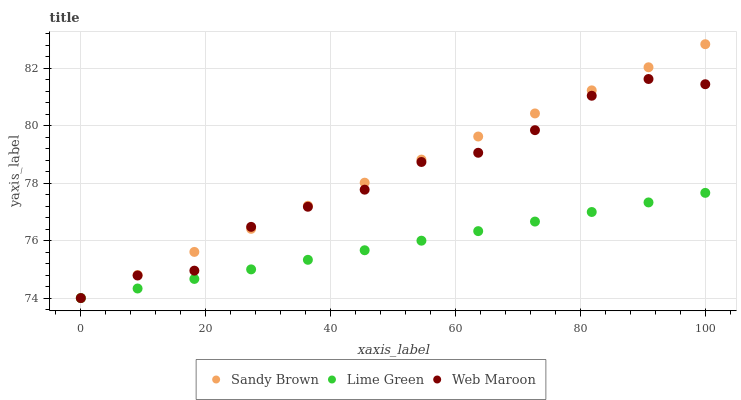Does Lime Green have the minimum area under the curve?
Answer yes or no. Yes. Does Sandy Brown have the maximum area under the curve?
Answer yes or no. Yes. Does Web Maroon have the minimum area under the curve?
Answer yes or no. No. Does Web Maroon have the maximum area under the curve?
Answer yes or no. No. Is Lime Green the smoothest?
Answer yes or no. Yes. Is Web Maroon the roughest?
Answer yes or no. Yes. Is Sandy Brown the smoothest?
Answer yes or no. No. Is Sandy Brown the roughest?
Answer yes or no. No. Does Lime Green have the lowest value?
Answer yes or no. Yes. Does Sandy Brown have the highest value?
Answer yes or no. Yes. Does Web Maroon have the highest value?
Answer yes or no. No. Does Web Maroon intersect Lime Green?
Answer yes or no. Yes. Is Web Maroon less than Lime Green?
Answer yes or no. No. Is Web Maroon greater than Lime Green?
Answer yes or no. No. 